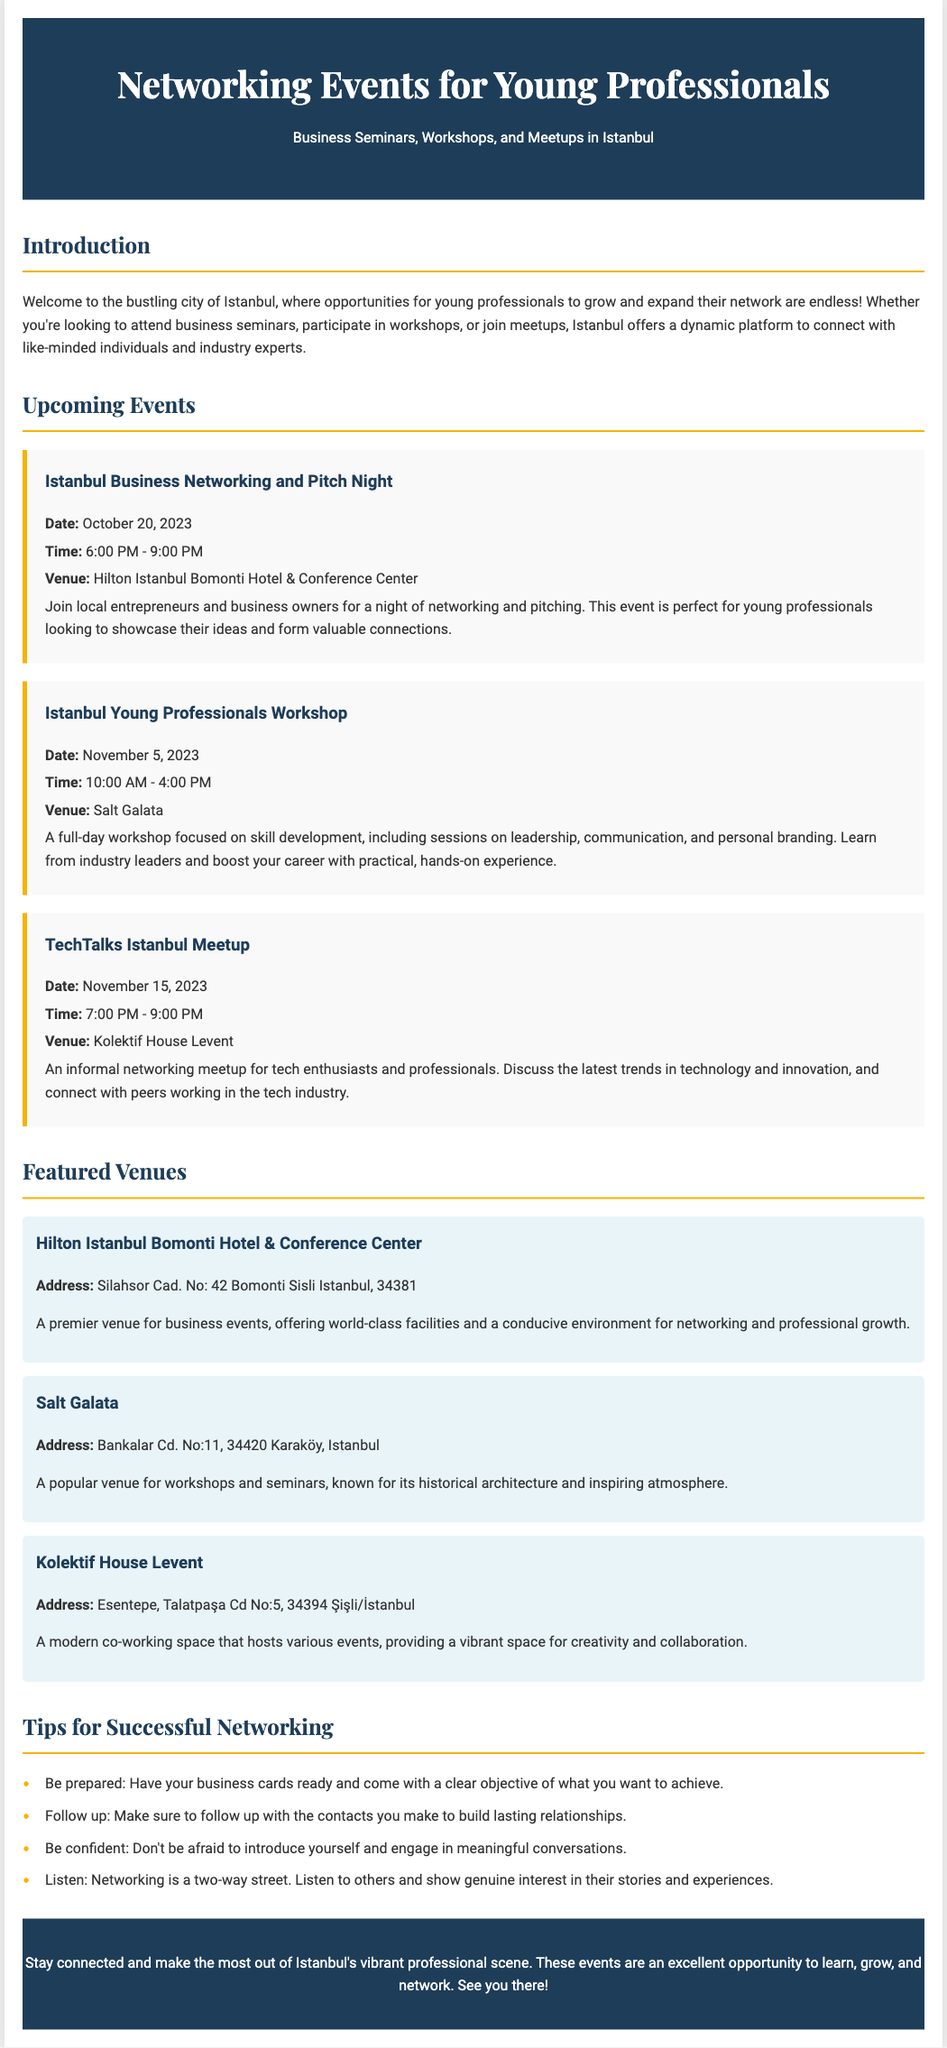What is the title of the first event? The title of the first event listed under Upcoming Events is "Istanbul Business Networking and Pitch Night."
Answer: Istanbul Business Networking and Pitch Night What is the date of the Istanbul Young Professionals Workshop? The date is specifically mentioned in the event details as November 5, 2023.
Answer: November 5, 2023 What time does the TechTalks Istanbul Meetup start? The start time is clearly stated in the event details as 7:00 PM.
Answer: 7:00 PM Which venue is hosting the Istanbul Business Networking and Pitch Night? The venue for this event is prominently mentioned as Hilton Istanbul Bomonti Hotel & Conference Center.
Answer: Hilton Istanbul Bomonti Hotel & Conference Center How long is the Istanbul Young Professionals Workshop? The duration is indicated in the event description, which states it runs from 10:00 AM to 4:00 PM, making it a full-day event.
Answer: 6 hours What type of space is Kolektif House Levent? The document describes Kolektif House Levent as a modern co-working space.
Answer: modern co-working space What are participants encouraged to have ready for networking? The document states that participants should have their business cards ready for networking.
Answer: business cards What is the address of Salt Galata? The address is clearly provided in the venue section as Bankalar Cd. No:11, 34420 Karaköy, Istanbul.
Answer: Bankalar Cd. No:11, 34420 Karaköy, Istanbul How many tips for successful networking are listed? The document includes a list of four specific tips for successful networking.
Answer: 4 